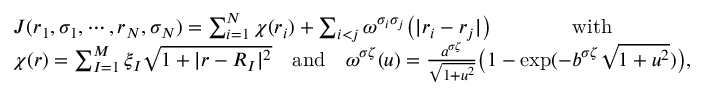<formula> <loc_0><loc_0><loc_500><loc_500>\begin{array} { r l } & { J ( r _ { 1 } , \sigma _ { 1 } , \cdots , r _ { N } , \sigma _ { N } ) = \sum _ { i = 1 } ^ { N } \chi ( r _ { i } ) + \sum _ { i < j } \omega ^ { \sigma _ { i } \sigma _ { j } } \left ( | r _ { i } - r _ { j } | \right ) \quad w i t h } \\ & { \chi ( r ) = \sum _ { I = 1 } ^ { M } \xi _ { I } \sqrt { 1 + | r - R _ { I } | ^ { 2 } } \quad a n d \quad \omega ^ { \sigma \zeta } ( u ) = \frac { a ^ { \sigma \zeta } } { \sqrt { 1 + u ^ { 2 } } } \left ( 1 - \exp ( - b ^ { \sigma \zeta } \sqrt { 1 + u ^ { 2 } } ) \right ) , } \end{array}</formula> 